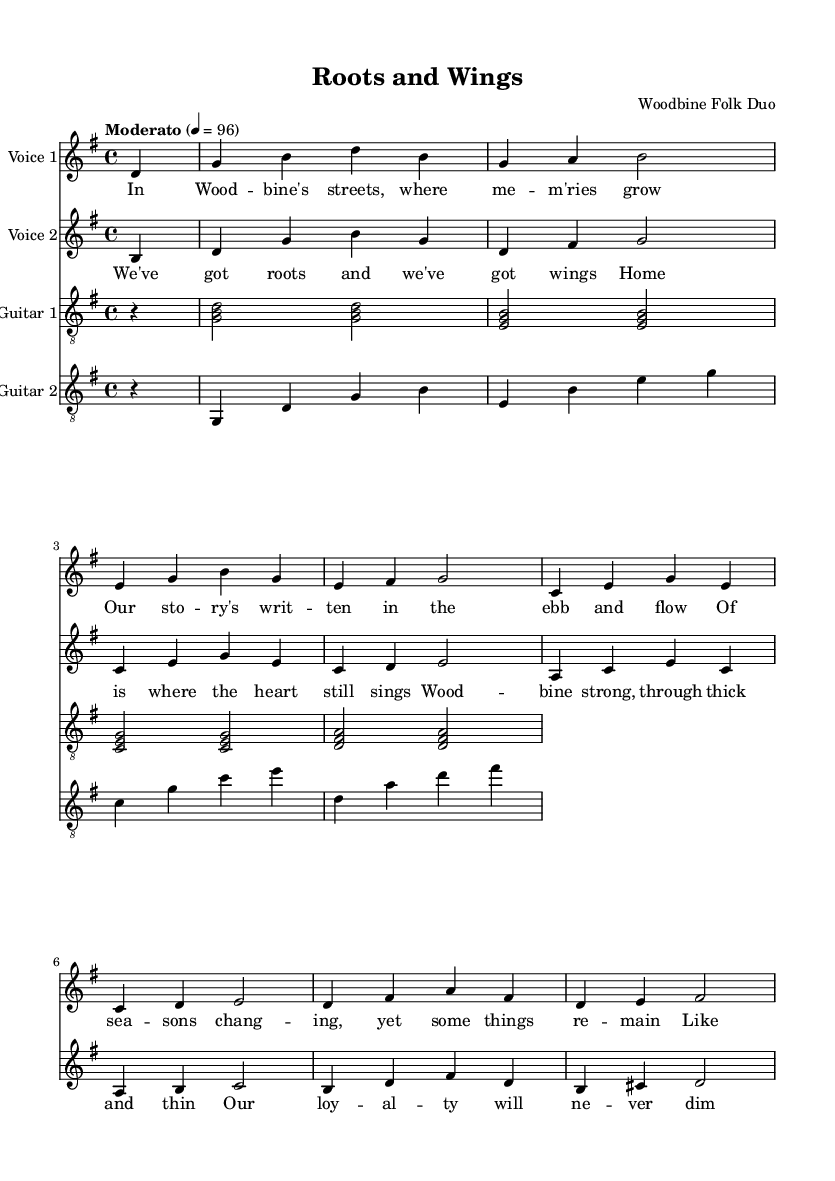What is the key signature of this music? The key signature indicated at the beginning of the sheet music is G major, which features one sharp (F#).
Answer: G major What is the time signature of the piece? The time signature displayed in the music is 4/4, meaning there are four beats in a measure and the quarter note gets one beat.
Answer: 4/4 What is the tempo marking for this piece? The tempo marking specified is "Moderato," which indicates a moderate pace, generally around 96 beats per minute.
Answer: Moderato How many verses are in the lyrics? The lyrics presented feature one verse and one chorus, with the verse clearly indicated in the content of the music.
Answer: One What instruments are included in this score? The score includes two vocal parts and two guitar parts, as noted in the headers for each staff.
Answer: Two voices and two guitars What themes are conveyed in the lyrics? The lyrics emphasize themes of love, hometown loyalty, and enduring relationships, which reflect the romantic aspect of the piece.
Answer: Love and hometown loyalty How does the structure of the song support its romantic theme? The song's structure includes a verse and a chorus, with the verse narrating shared experiences and the chorus uplifting the sense of belonging and loyalty, typical of romantic music.
Answer: Verse and chorus structure 